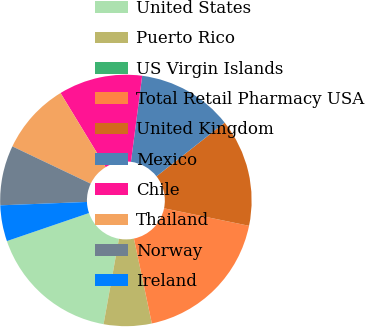<chart> <loc_0><loc_0><loc_500><loc_500><pie_chart><fcel>United States<fcel>Puerto Rico<fcel>US Virgin Islands<fcel>Total Retail Pharmacy USA<fcel>United Kingdom<fcel>Mexico<fcel>Chile<fcel>Thailand<fcel>Norway<fcel>Ireland<nl><fcel>16.92%<fcel>6.15%<fcel>0.0%<fcel>18.46%<fcel>13.85%<fcel>12.31%<fcel>10.77%<fcel>9.23%<fcel>7.69%<fcel>4.62%<nl></chart> 